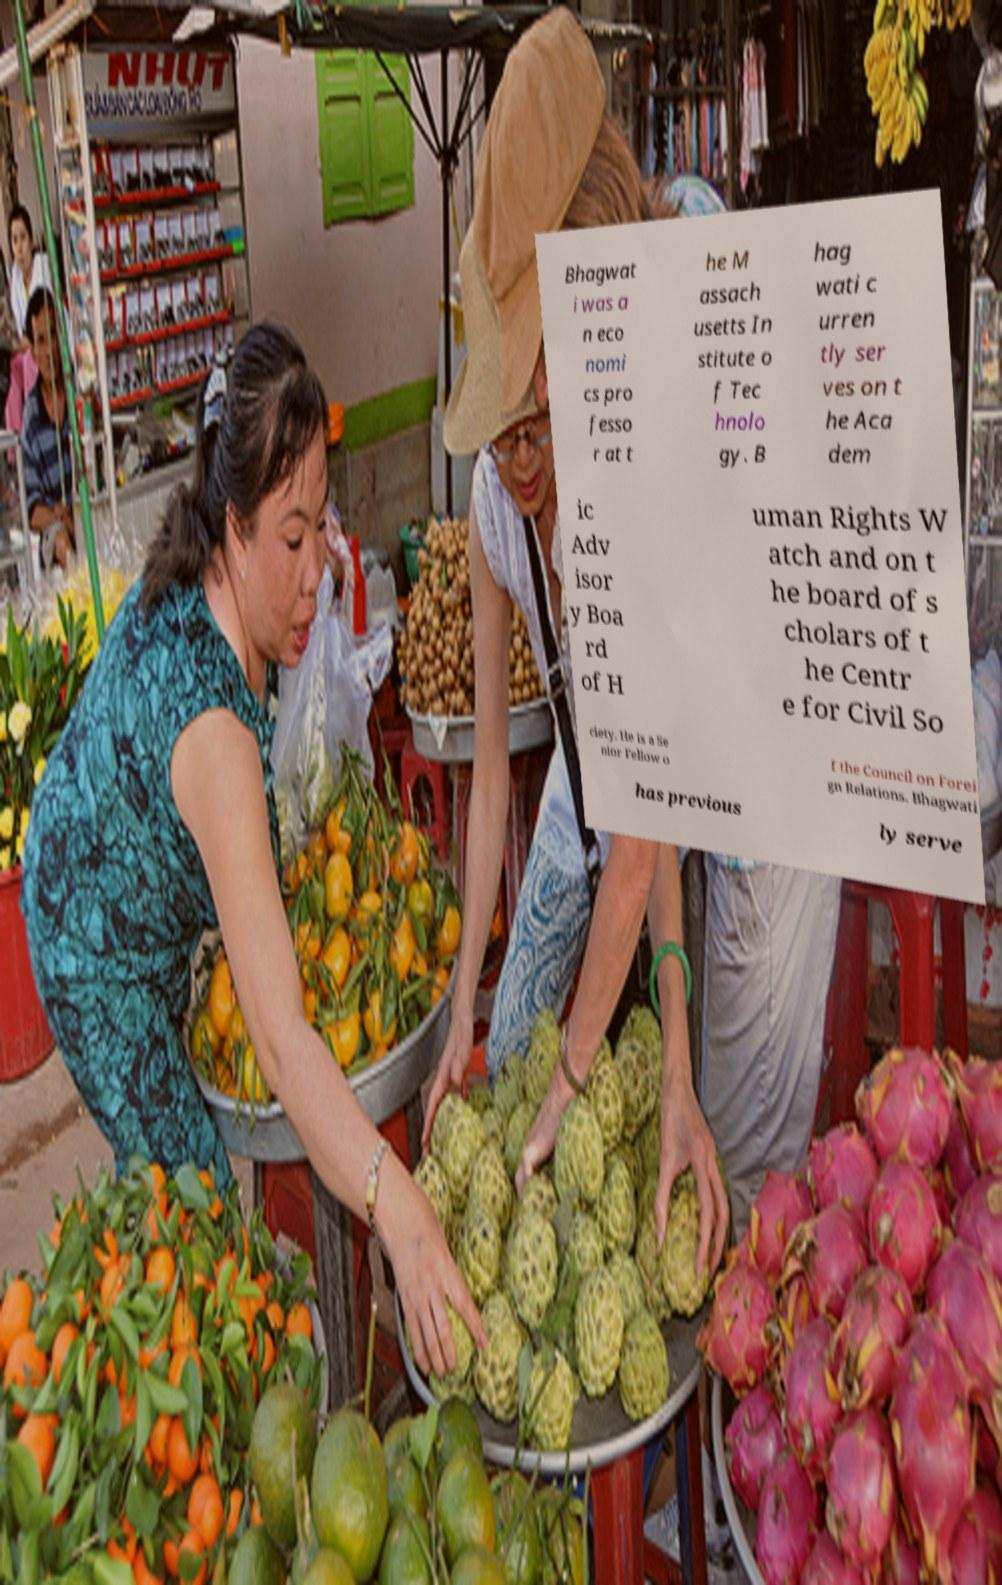Please identify and transcribe the text found in this image. Bhagwat i was a n eco nomi cs pro fesso r at t he M assach usetts In stitute o f Tec hnolo gy. B hag wati c urren tly ser ves on t he Aca dem ic Adv isor y Boa rd of H uman Rights W atch and on t he board of s cholars of t he Centr e for Civil So ciety. He is a Se nior Fellow o f the Council on Forei gn Relations. Bhagwati has previous ly serve 